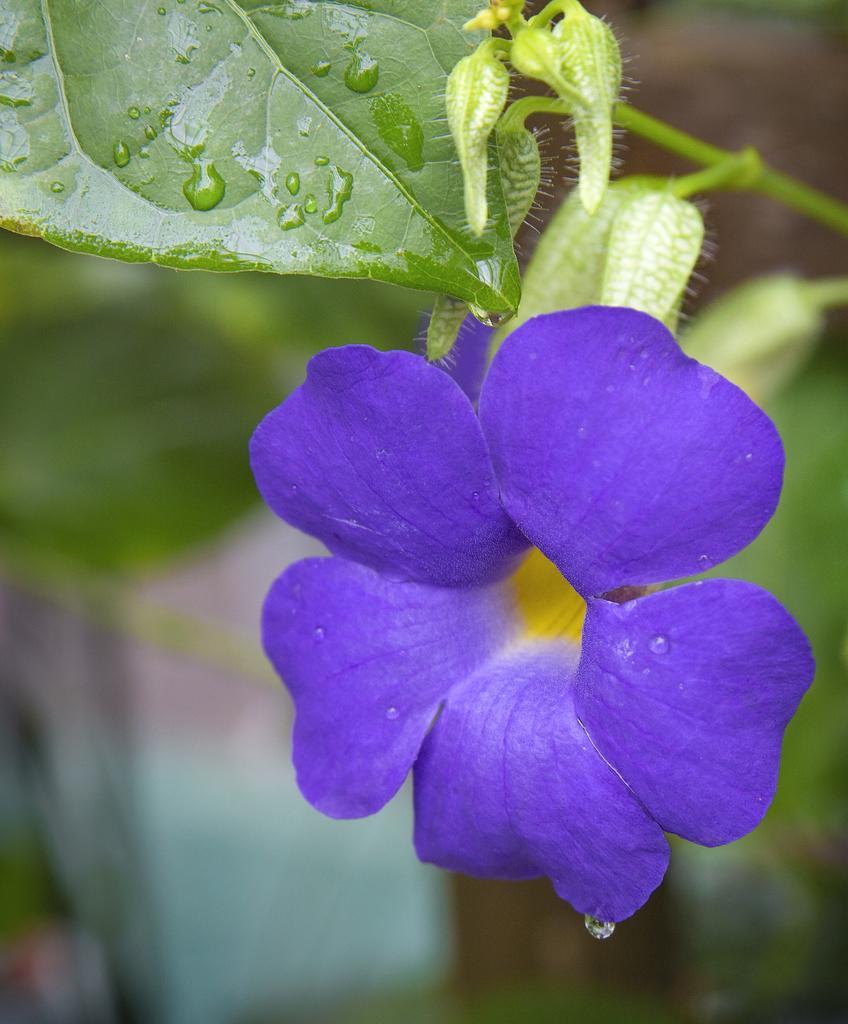Can you describe this image briefly? In this image we can see the flowers and buds on the plant, also we can see the background is blurred. 